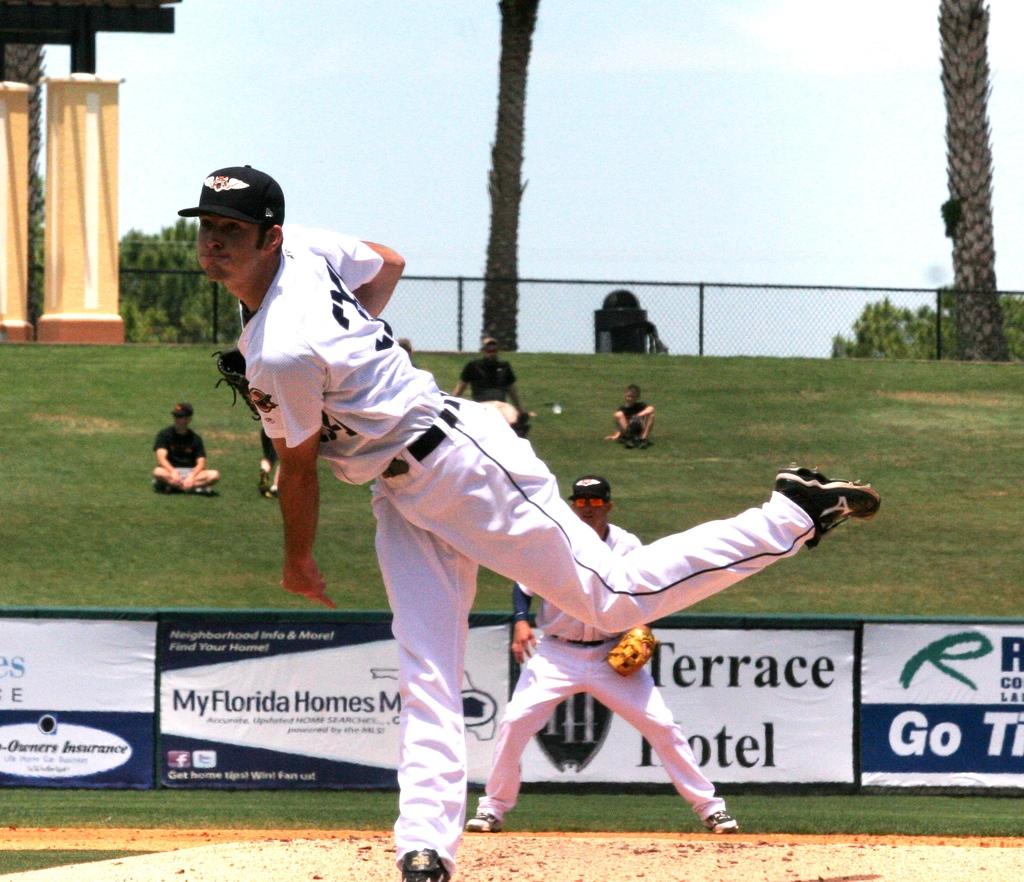What is the big green letter on the sign in the back?
Provide a short and direct response. R. 